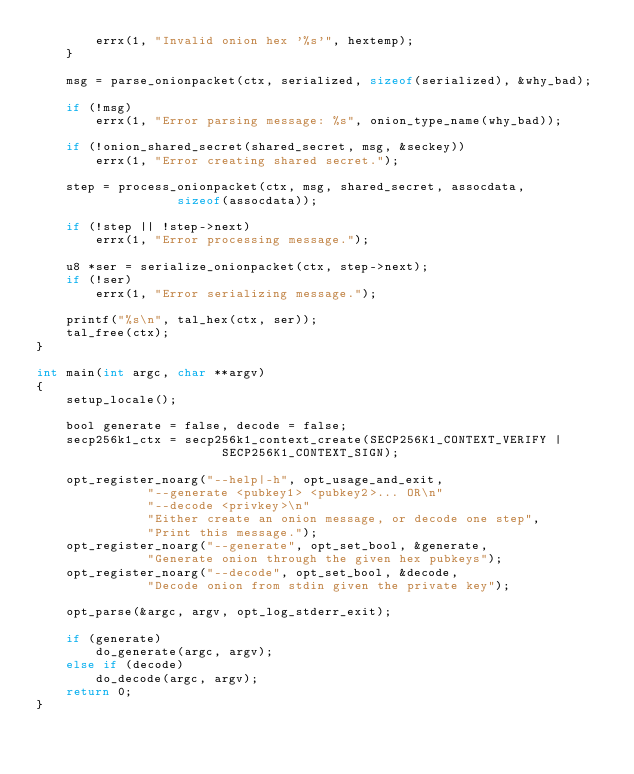<code> <loc_0><loc_0><loc_500><loc_500><_C_>		errx(1, "Invalid onion hex '%s'", hextemp);
	}

	msg = parse_onionpacket(ctx, serialized, sizeof(serialized), &why_bad);

	if (!msg)
		errx(1, "Error parsing message: %s", onion_type_name(why_bad));

	if (!onion_shared_secret(shared_secret, msg, &seckey))
		errx(1, "Error creating shared secret.");

	step = process_onionpacket(ctx, msg, shared_secret, assocdata,
				   sizeof(assocdata));

	if (!step || !step->next)
		errx(1, "Error processing message.");

	u8 *ser = serialize_onionpacket(ctx, step->next);
	if (!ser)
		errx(1, "Error serializing message.");

	printf("%s\n", tal_hex(ctx, ser));
	tal_free(ctx);
}

int main(int argc, char **argv)
{
	setup_locale();

	bool generate = false, decode = false;
	secp256k1_ctx = secp256k1_context_create(SECP256K1_CONTEXT_VERIFY |
						 SECP256K1_CONTEXT_SIGN);

	opt_register_noarg("--help|-h", opt_usage_and_exit,
			   "--generate <pubkey1> <pubkey2>... OR\n"
			   "--decode <privkey>\n"
			   "Either create an onion message, or decode one step",
			   "Print this message.");
	opt_register_noarg("--generate", opt_set_bool, &generate,
			   "Generate onion through the given hex pubkeys");
	opt_register_noarg("--decode", opt_set_bool, &decode,
			   "Decode onion from stdin given the private key");

	opt_parse(&argc, argv, opt_log_stderr_exit);

	if (generate)
		do_generate(argc, argv);
	else if (decode)
		do_decode(argc, argv);
	return 0;
}
</code> 